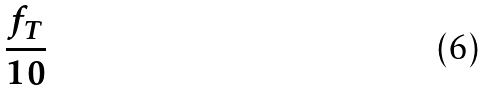Convert formula to latex. <formula><loc_0><loc_0><loc_500><loc_500>\frac { f _ { T } } { 1 0 }</formula> 